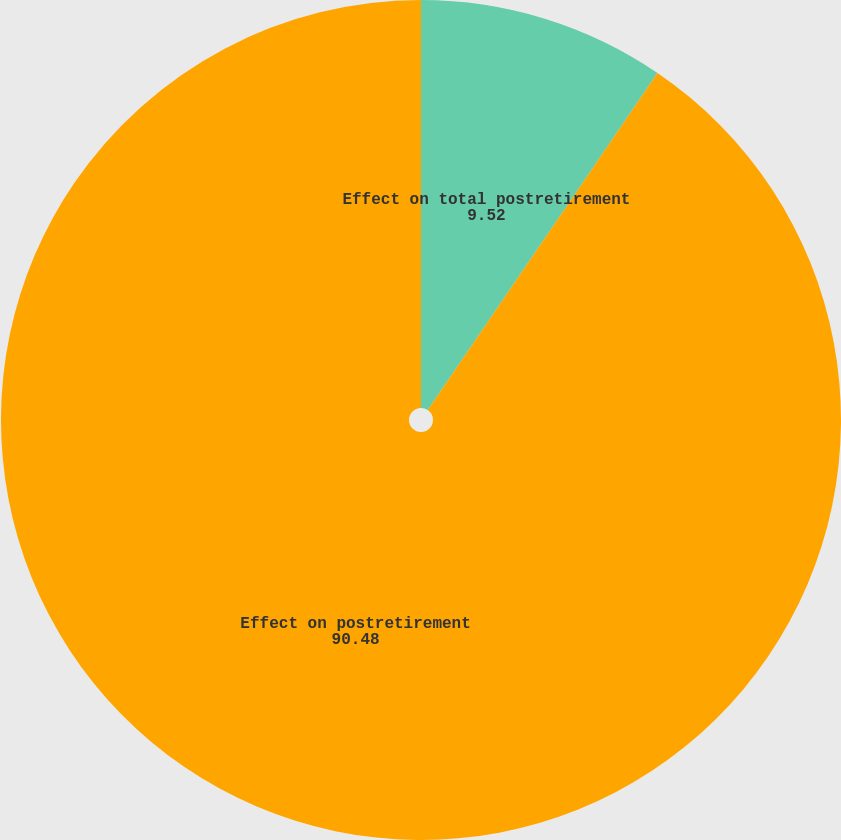Convert chart. <chart><loc_0><loc_0><loc_500><loc_500><pie_chart><fcel>Effect on total postretirement<fcel>Effect on postretirement<nl><fcel>9.52%<fcel>90.48%<nl></chart> 